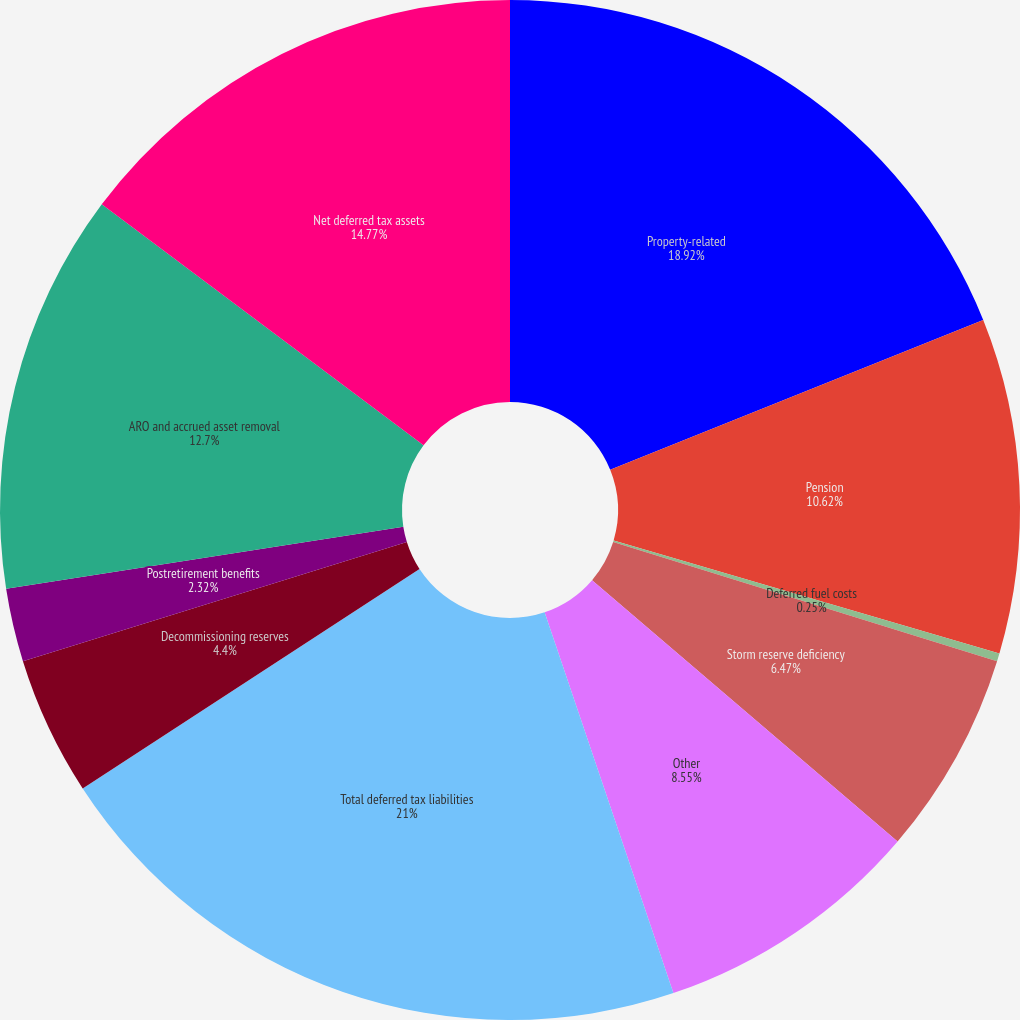Convert chart. <chart><loc_0><loc_0><loc_500><loc_500><pie_chart><fcel>Property-related<fcel>Pension<fcel>Deferred fuel costs<fcel>Storm reserve deficiency<fcel>Other<fcel>Total deferred tax liabilities<fcel>Decommissioning reserves<fcel>Postretirement benefits<fcel>ARO and accrued asset removal<fcel>Net deferred tax assets<nl><fcel>18.92%<fcel>10.62%<fcel>0.25%<fcel>6.47%<fcel>8.55%<fcel>21.0%<fcel>4.4%<fcel>2.32%<fcel>12.7%<fcel>14.77%<nl></chart> 